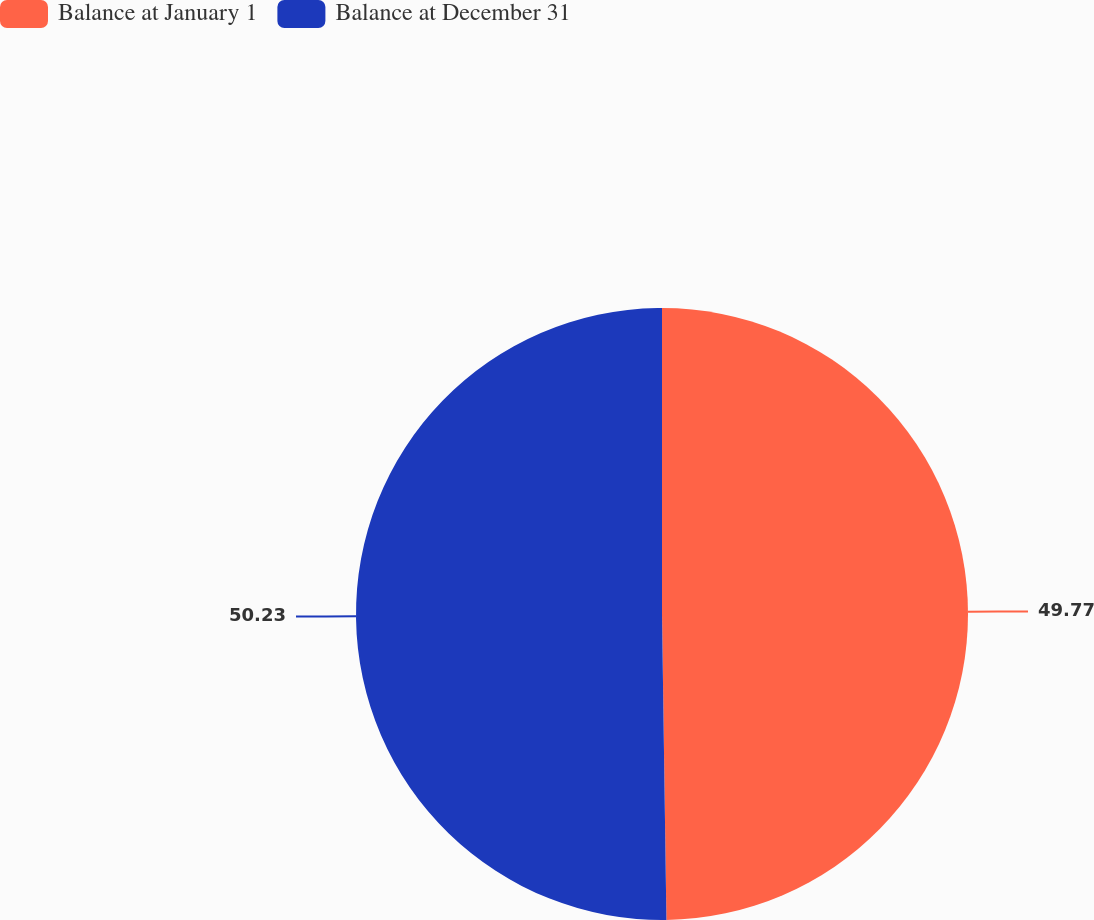Convert chart to OTSL. <chart><loc_0><loc_0><loc_500><loc_500><pie_chart><fcel>Balance at January 1<fcel>Balance at December 31<nl><fcel>49.77%<fcel>50.23%<nl></chart> 